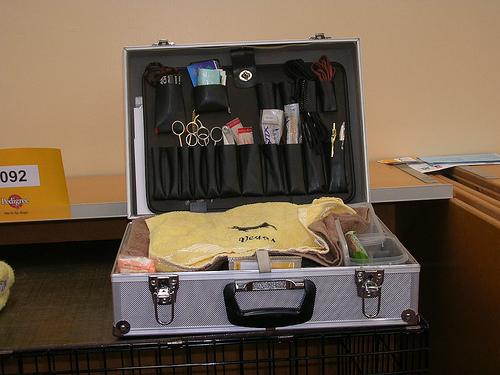Question: how is the case?
Choices:
A. Messy.
B. Empty.
C. Broken.
D. Arranged.
Answer with the letter. Answer: D 